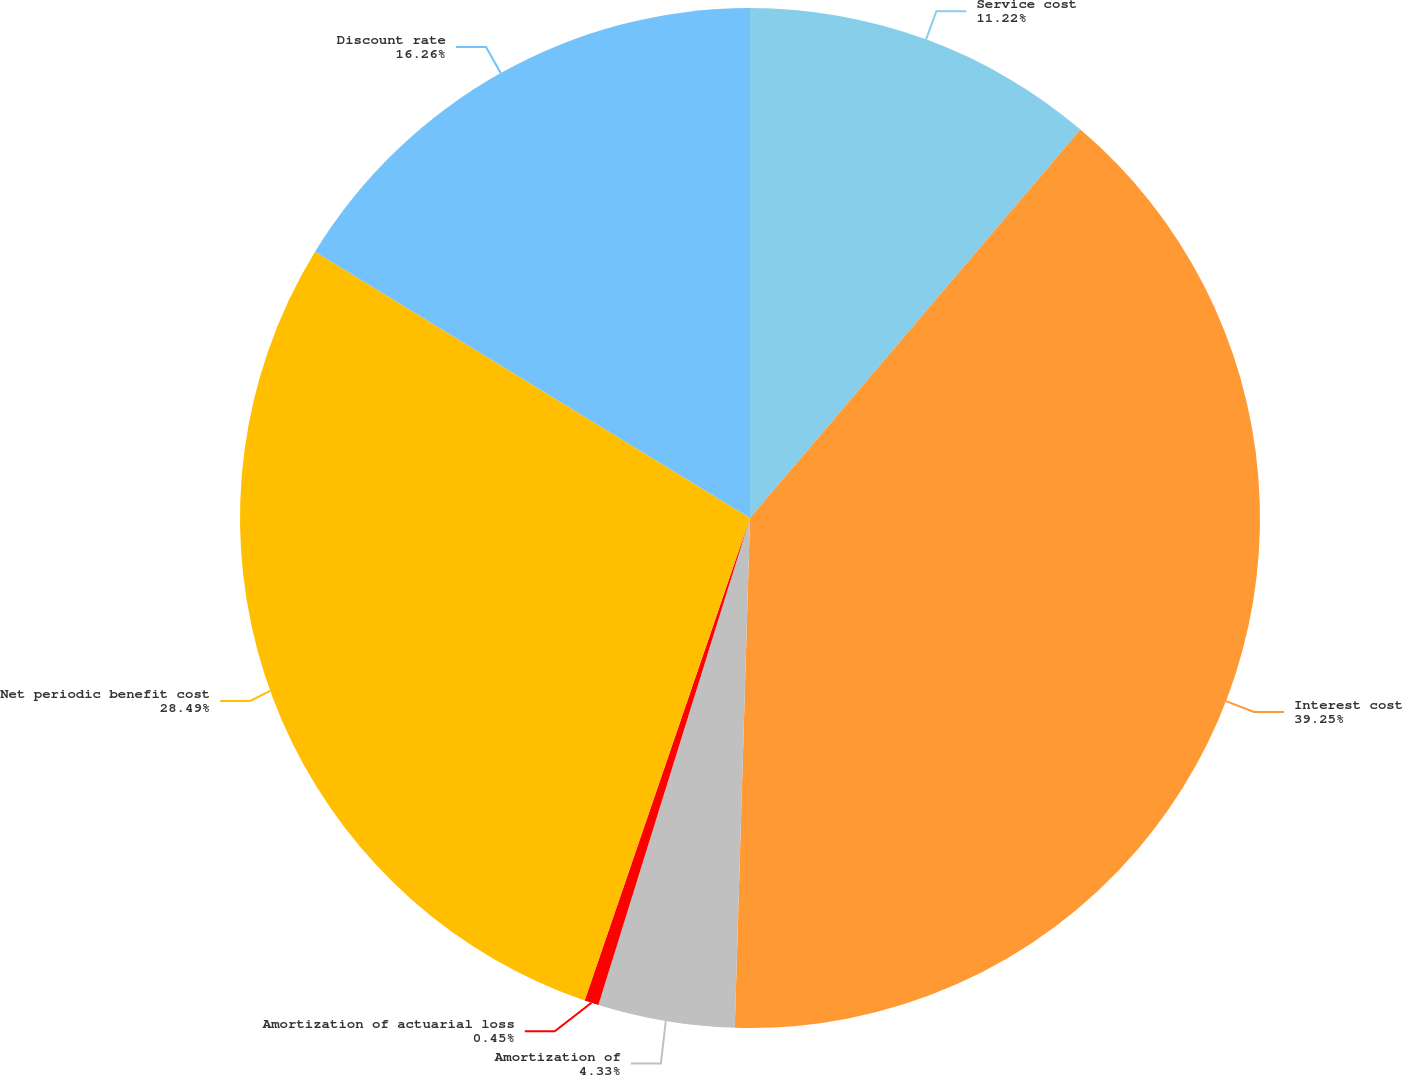<chart> <loc_0><loc_0><loc_500><loc_500><pie_chart><fcel>Service cost<fcel>Interest cost<fcel>Amortization of<fcel>Amortization of actuarial loss<fcel>Net periodic benefit cost<fcel>Discount rate<nl><fcel>11.22%<fcel>39.26%<fcel>4.33%<fcel>0.45%<fcel>28.49%<fcel>16.26%<nl></chart> 